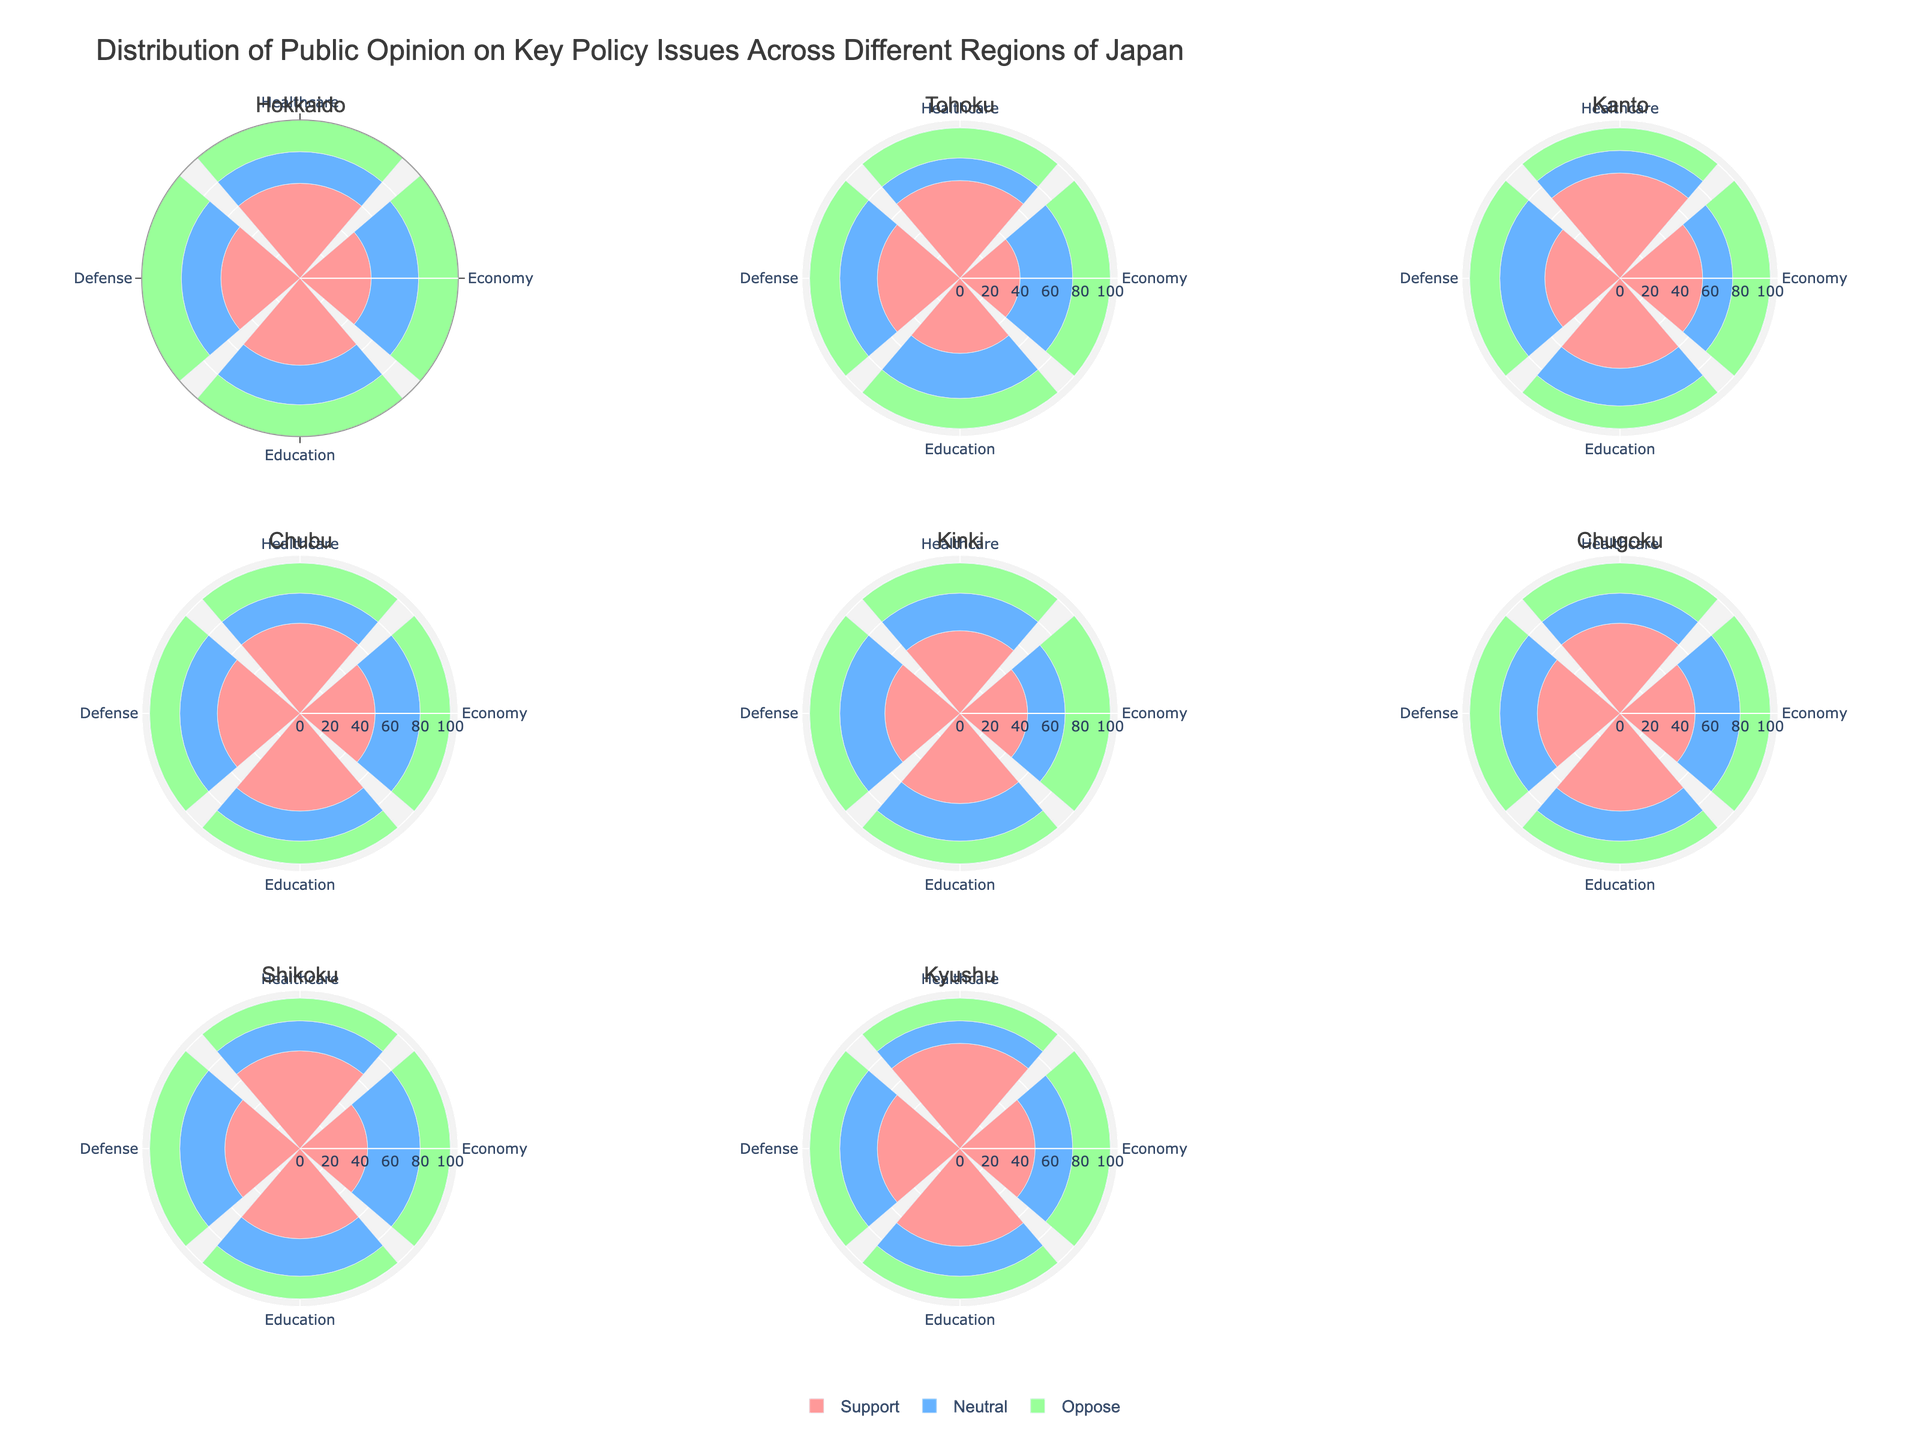What is the title of the figure? The title is usually located at the top of the figure and serves to describe the main content. In this case, look at the top center to find the title detailing public opinion distribution across different regions.
Answer: Distribution of Public Opinion on Key Policy Issues Across Different Regions of Japan What color represents the "Support" percentage in each subplot? Each group of colors in the figure legend identifies the corresponding opinion category. "Support" is marked with a pinkish color, which is the first color in each barpolar subplot.
Answer: Pinkish In which region is healthcare support the highest? By examining the heights of the bars labeled 'Healthcare' in all the regions' subplots, we find that the region with the tallest 'Support' bar for healthcare is Kanto and Kyushu, both reaching 70%.
Answer: Kanto and Kyushu Which policy issue has the highest level of opposition in Tohoku? Look for the 'Oppose' percentage in the Tohoku subplot. Check each issue and identify the tallest oppose bar. It is clear that the 'Economy' policy issue has the highest opposition at 25%.
Answer: Economy How many regions have a neutral opinion percentage of 20% on defense? Inspect each subplot and focus on the 'Neutral' percentage for the defense policy issue. Count the number of regions where the 'Neutral' bar is exactly 20%. This occurs in Hokkaido, Tohoku, Chubu, and Kyushu.
Answer: Four Which region shows the greatest support for education, and what is its percentage? Compare the 'Support' percentage bars for the 'Education' policy issue across all subplots. The region with the highest bar for education support is Chubu with 65%.
Answer: Chubu, 65% In which region is the opposition to economic policies more significant than support? Compare the heights of the 'Support' and 'Oppose' bars for the Economy policy issue in each region. In Kinki, the 'Oppose' bar is higher than the 'Support' bar (30% oppose vs. 25% support).
Answer: Kinki Which policy issue has the most consistent support, and what is the range across all regions? For each policy issue, check the 'Support' percentages across all subplots. Calculate the range (highest percentage minus lowest percentage) for each issue. Education has the most consistent support with a range (65 - 50) = 15.
Answer: Education, 15 